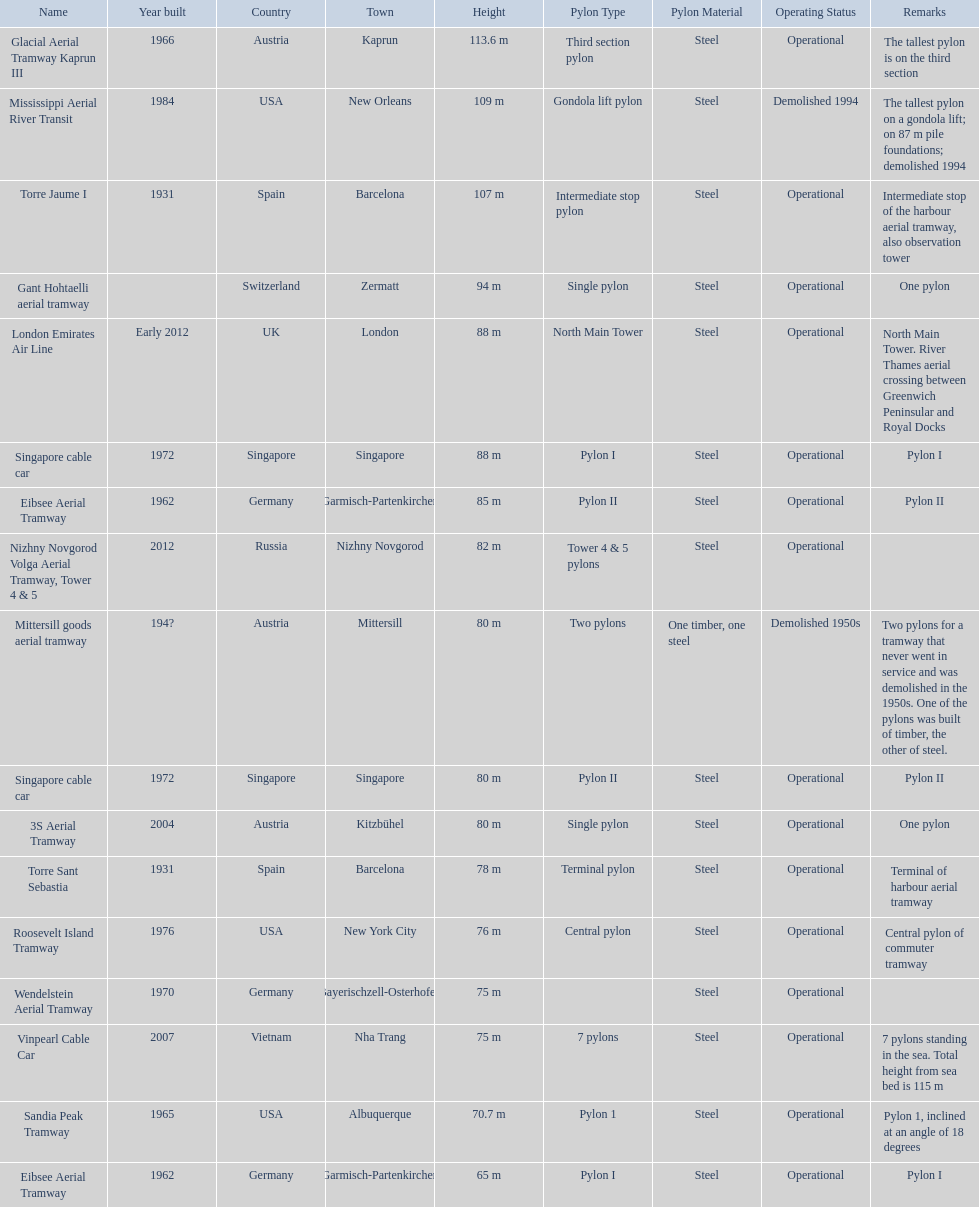Which lift has the second highest height? Mississippi Aerial River Transit. What is the value of the height? 109 m. 